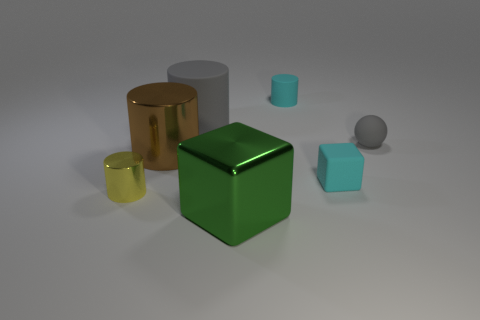There is a small cylinder that is on the left side of the shiny cylinder on the right side of the yellow cylinder; how many large things are behind it?
Make the answer very short. 2. Are there any rubber cylinders in front of the tiny cyan rubber block?
Offer a terse response. No. Are there any other things of the same color as the small rubber cylinder?
Your answer should be compact. Yes. How many cylinders are shiny things or big brown objects?
Offer a terse response. 2. How many big objects are in front of the gray rubber sphere and behind the metallic cube?
Your answer should be compact. 1. Are there an equal number of small matte cubes that are behind the small gray thing and gray cylinders in front of the rubber block?
Provide a short and direct response. Yes. Does the gray rubber object that is on the right side of the cyan rubber cylinder have the same shape as the large matte thing?
Your answer should be very brief. No. There is a gray rubber thing to the right of the large gray matte cylinder behind the tiny cyan rubber block that is on the right side of the green shiny block; what shape is it?
Your response must be concise. Sphere. There is a big matte object that is the same color as the tiny ball; what is its shape?
Provide a succinct answer. Cylinder. The tiny object that is behind the cyan block and left of the sphere is made of what material?
Offer a very short reply. Rubber. 